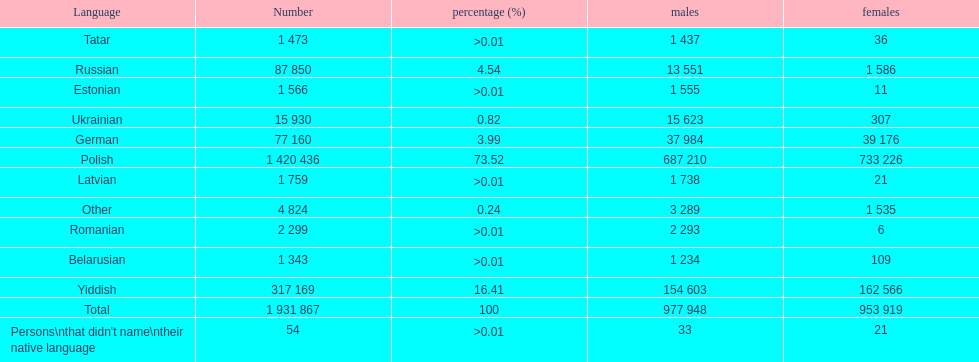Which language had the least female speakers? Romanian. 